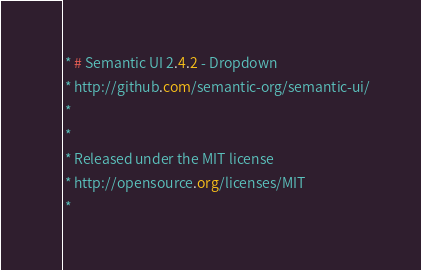<code> <loc_0><loc_0><loc_500><loc_500><_CSS_> * # Semantic UI 2.4.2 - Dropdown
 * http://github.com/semantic-org/semantic-ui/
 *
 *
 * Released under the MIT license
 * http://opensource.org/licenses/MIT
 *</code> 